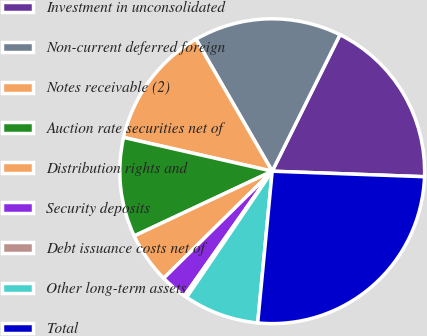Convert chart to OTSL. <chart><loc_0><loc_0><loc_500><loc_500><pie_chart><fcel>Investment in unconsolidated<fcel>Non-current deferred foreign<fcel>Notes receivable (2)<fcel>Auction rate securities net of<fcel>Distribution rights and<fcel>Security deposits<fcel>Debt issuance costs net of<fcel>Other long-term assets<fcel>Total<nl><fcel>18.24%<fcel>15.67%<fcel>13.11%<fcel>10.54%<fcel>5.41%<fcel>2.84%<fcel>0.28%<fcel>7.97%<fcel>25.94%<nl></chart> 